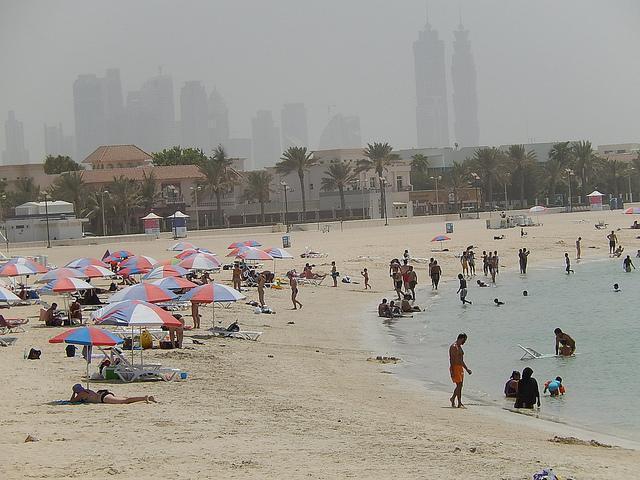Why are all the umbrellas there?
Answer the question by selecting the correct answer among the 4 following choices.
Options: Keep dry, for sale, left there, sun protection. Sun protection. 